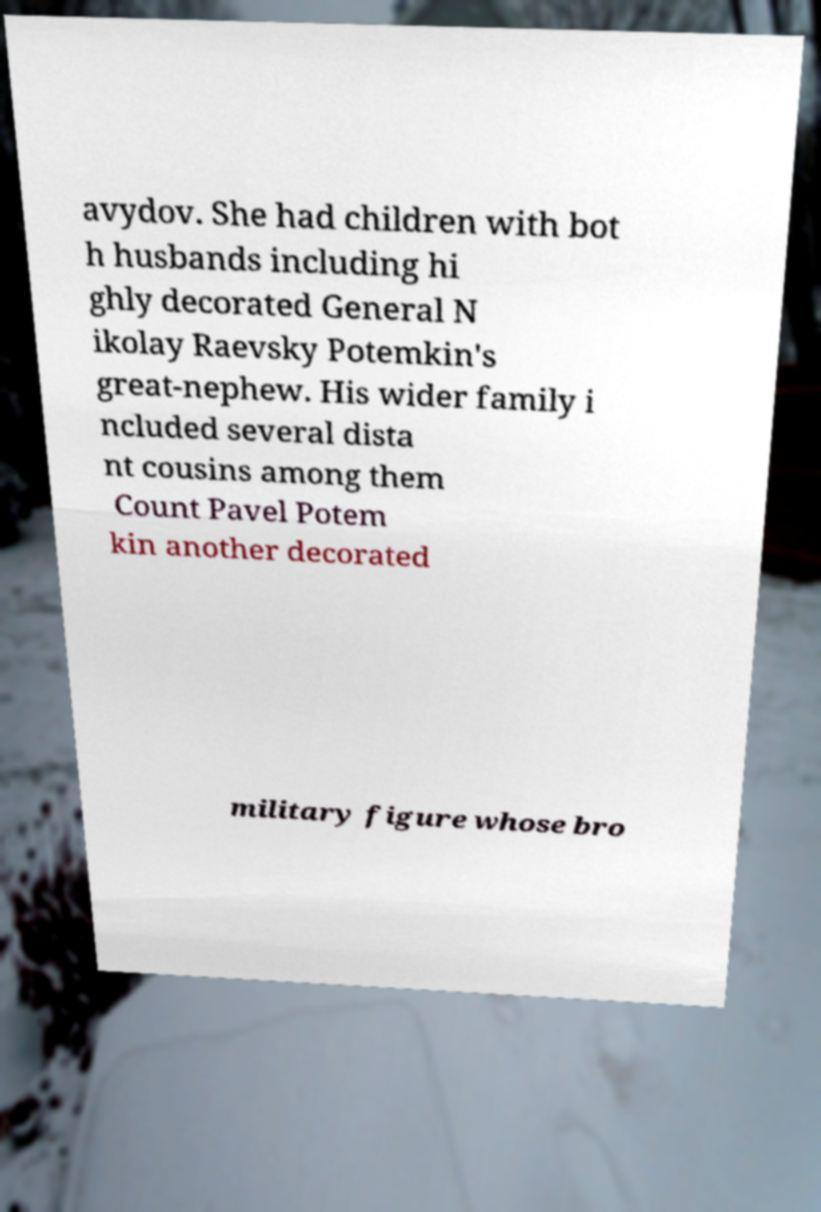Could you assist in decoding the text presented in this image and type it out clearly? avydov. She had children with bot h husbands including hi ghly decorated General N ikolay Raevsky Potemkin's great-nephew. His wider family i ncluded several dista nt cousins among them Count Pavel Potem kin another decorated military figure whose bro 